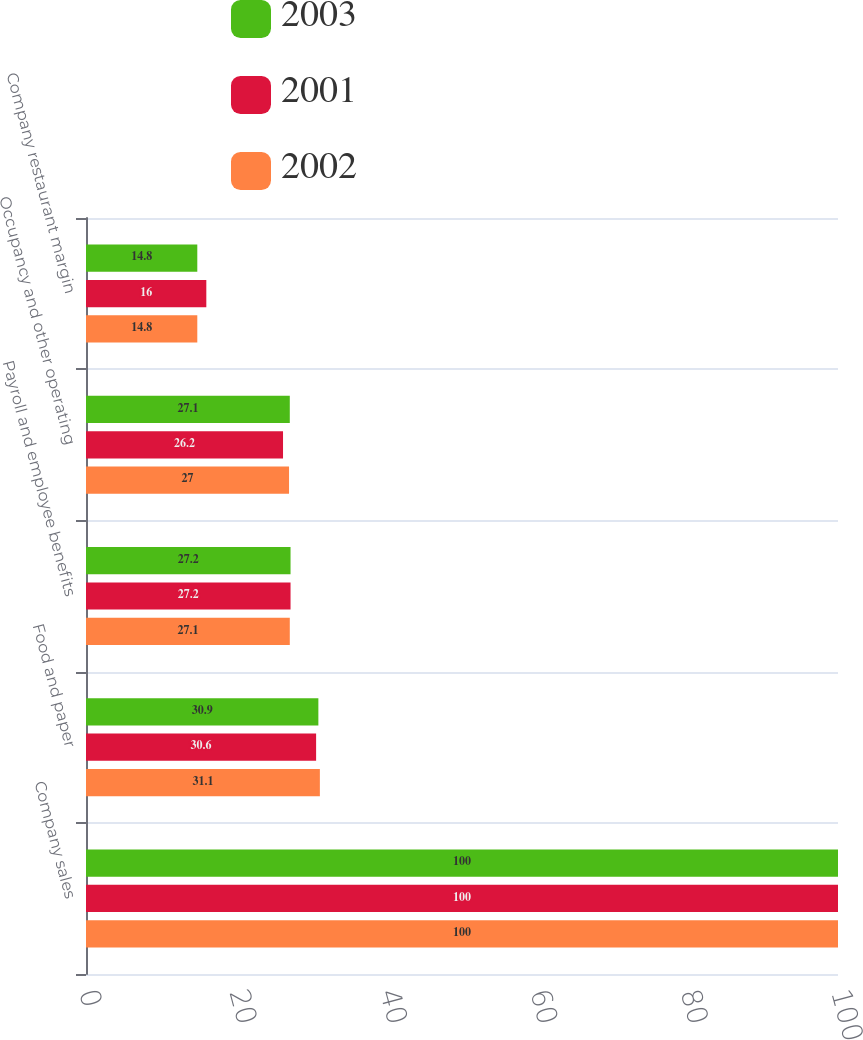<chart> <loc_0><loc_0><loc_500><loc_500><stacked_bar_chart><ecel><fcel>Company sales<fcel>Food and paper<fcel>Payroll and employee benefits<fcel>Occupancy and other operating<fcel>Company restaurant margin<nl><fcel>2003<fcel>100<fcel>30.9<fcel>27.2<fcel>27.1<fcel>14.8<nl><fcel>2001<fcel>100<fcel>30.6<fcel>27.2<fcel>26.2<fcel>16<nl><fcel>2002<fcel>100<fcel>31.1<fcel>27.1<fcel>27<fcel>14.8<nl></chart> 